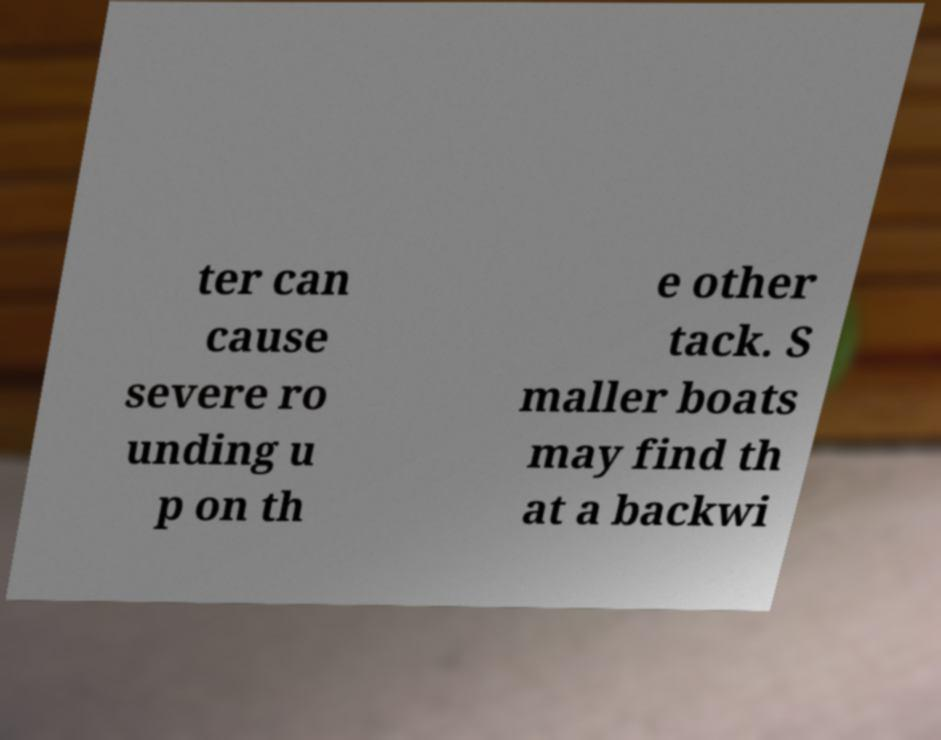I need the written content from this picture converted into text. Can you do that? ter can cause severe ro unding u p on th e other tack. S maller boats may find th at a backwi 